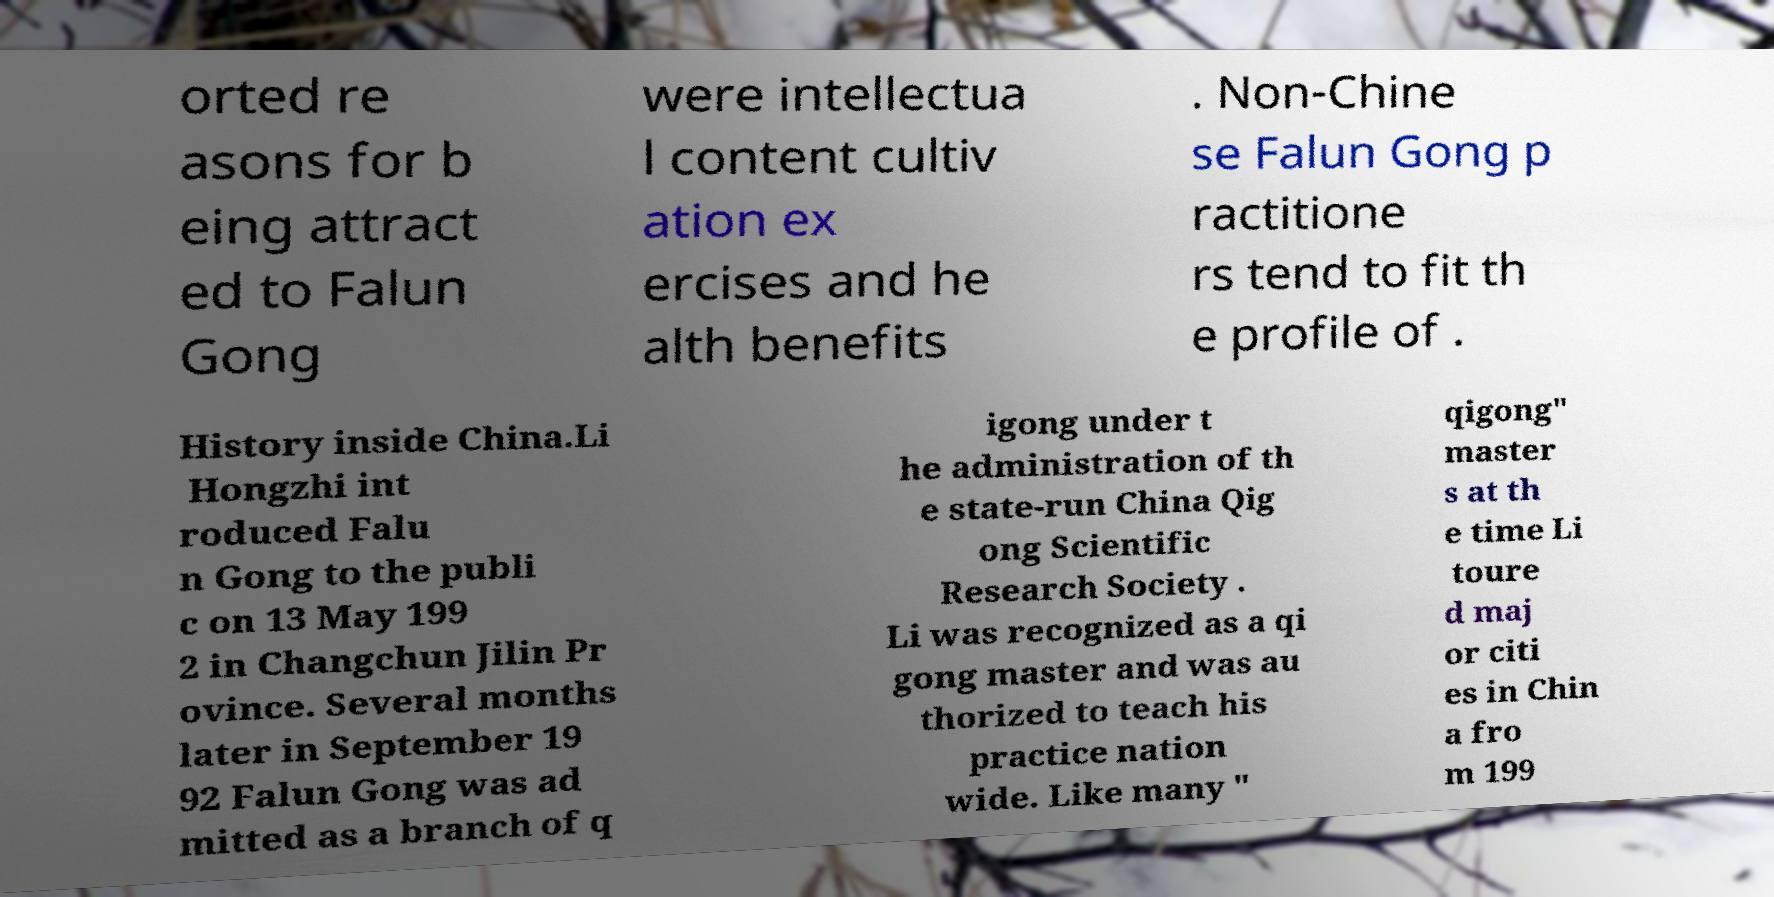What messages or text are displayed in this image? I need them in a readable, typed format. orted re asons for b eing attract ed to Falun Gong were intellectua l content cultiv ation ex ercises and he alth benefits . Non-Chine se Falun Gong p ractitione rs tend to fit th e profile of . History inside China.Li Hongzhi int roduced Falu n Gong to the publi c on 13 May 199 2 in Changchun Jilin Pr ovince. Several months later in September 19 92 Falun Gong was ad mitted as a branch of q igong under t he administration of th e state-run China Qig ong Scientific Research Society . Li was recognized as a qi gong master and was au thorized to teach his practice nation wide. Like many " qigong" master s at th e time Li toure d maj or citi es in Chin a fro m 199 